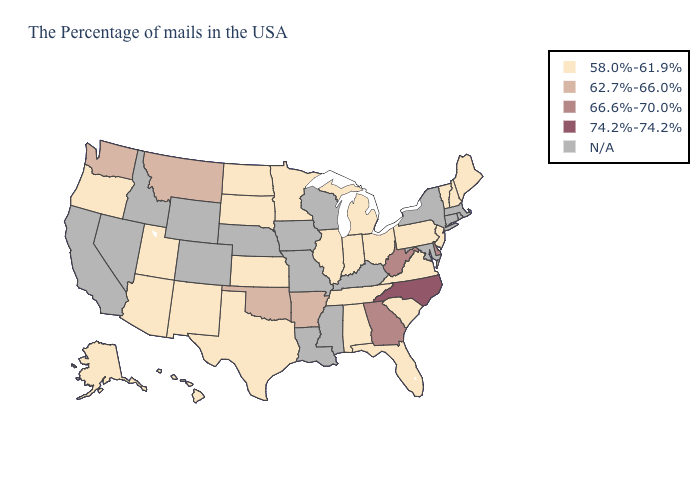Does the first symbol in the legend represent the smallest category?
Keep it brief. Yes. What is the value of West Virginia?
Quick response, please. 66.6%-70.0%. What is the value of Louisiana?
Quick response, please. N/A. What is the lowest value in the USA?
Keep it brief. 58.0%-61.9%. What is the value of South Dakota?
Keep it brief. 58.0%-61.9%. Name the states that have a value in the range 62.7%-66.0%?
Give a very brief answer. Arkansas, Oklahoma, Montana, Washington. What is the value of Florida?
Write a very short answer. 58.0%-61.9%. How many symbols are there in the legend?
Write a very short answer. 5. Does the map have missing data?
Short answer required. Yes. What is the value of Texas?
Be succinct. 58.0%-61.9%. Among the states that border New York , which have the lowest value?
Keep it brief. Vermont, New Jersey, Pennsylvania. Does West Virginia have the lowest value in the USA?
Write a very short answer. No. 